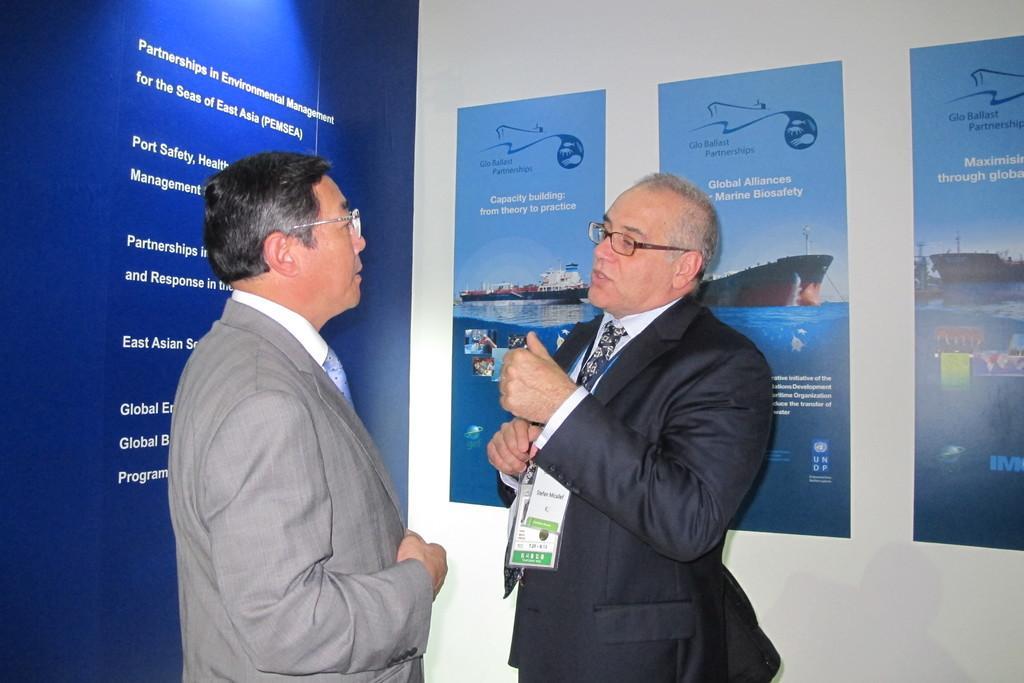Can you describe this image briefly? In this picture, we can see two persons, and we can see the wall, posters with some text and some images on it. 